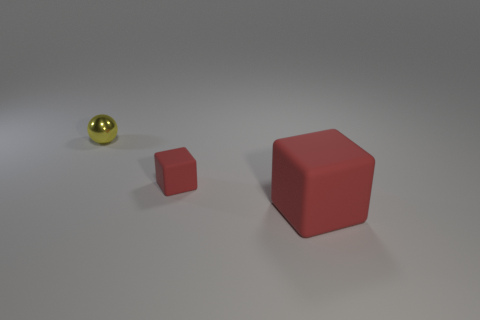Add 1 green shiny cylinders. How many objects exist? 4 Subtract all blocks. How many objects are left? 1 Subtract all cubes. Subtract all tiny brown shiny cubes. How many objects are left? 1 Add 1 big red matte blocks. How many big red matte blocks are left? 2 Add 1 big red cubes. How many big red cubes exist? 2 Subtract 0 red cylinders. How many objects are left? 3 